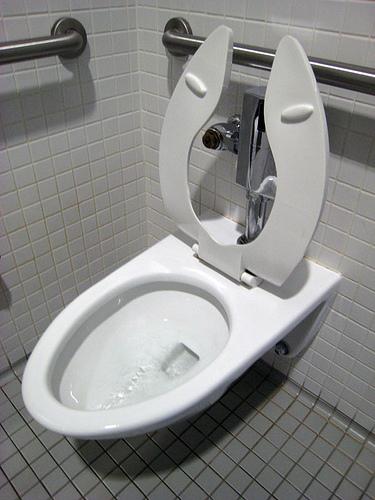Is the toilet clean?
Quick response, please. Yes. Is this a manual flusher?
Answer briefly. No. Is water running in the toilet?
Answer briefly. Yes. 